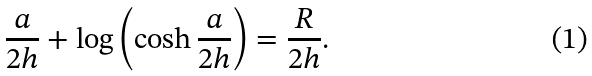Convert formula to latex. <formula><loc_0><loc_0><loc_500><loc_500>\frac { a } { 2 h } + \log \left ( \cosh \frac { a } { 2 h } \right ) = \frac { R } { 2 h } .</formula> 